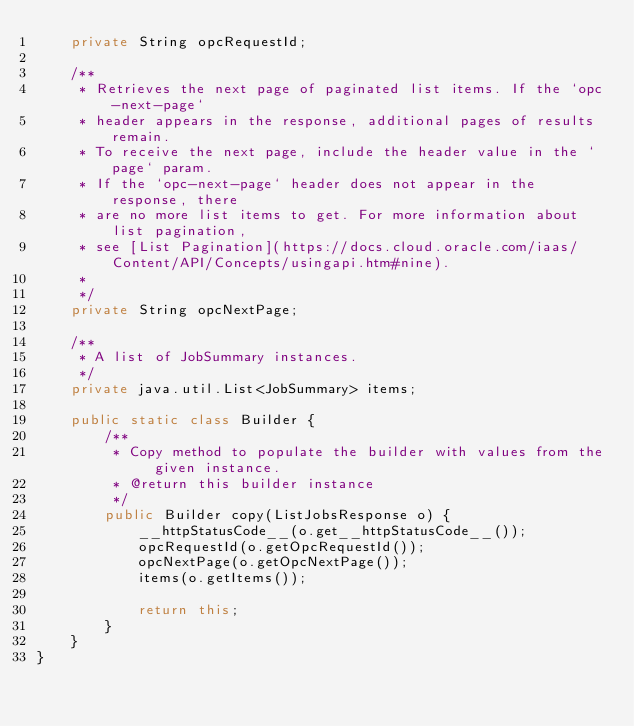<code> <loc_0><loc_0><loc_500><loc_500><_Java_>    private String opcRequestId;

    /**
     * Retrieves the next page of paginated list items. If the `opc-next-page`
     * header appears in the response, additional pages of results remain.
     * To receive the next page, include the header value in the `page` param.
     * If the `opc-next-page` header does not appear in the response, there
     * are no more list items to get. For more information about list pagination,
     * see [List Pagination](https://docs.cloud.oracle.com/iaas/Content/API/Concepts/usingapi.htm#nine).
     *
     */
    private String opcNextPage;

    /**
     * A list of JobSummary instances.
     */
    private java.util.List<JobSummary> items;

    public static class Builder {
        /**
         * Copy method to populate the builder with values from the given instance.
         * @return this builder instance
         */
        public Builder copy(ListJobsResponse o) {
            __httpStatusCode__(o.get__httpStatusCode__());
            opcRequestId(o.getOpcRequestId());
            opcNextPage(o.getOpcNextPage());
            items(o.getItems());

            return this;
        }
    }
}
</code> 